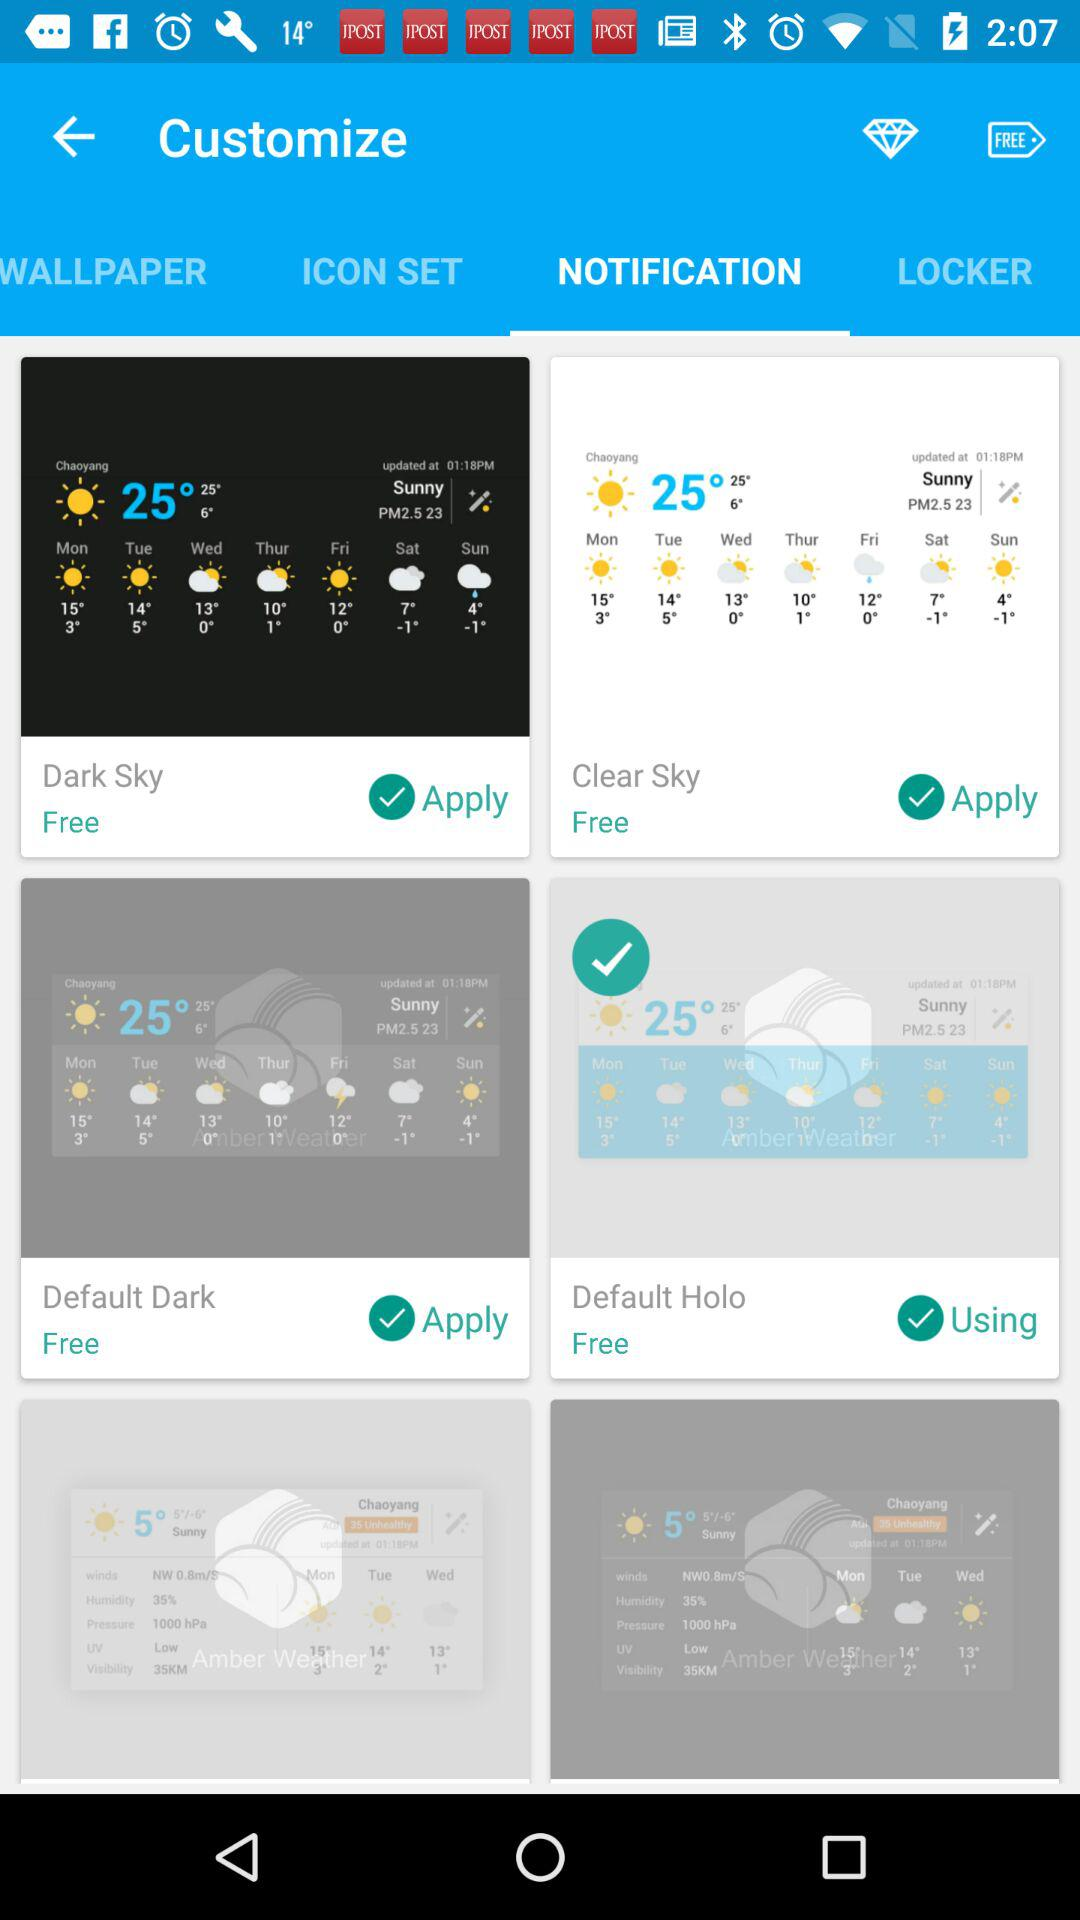Which option is selected in "Customize"? The selected option in "Customize" is "NOTIFICATION". 